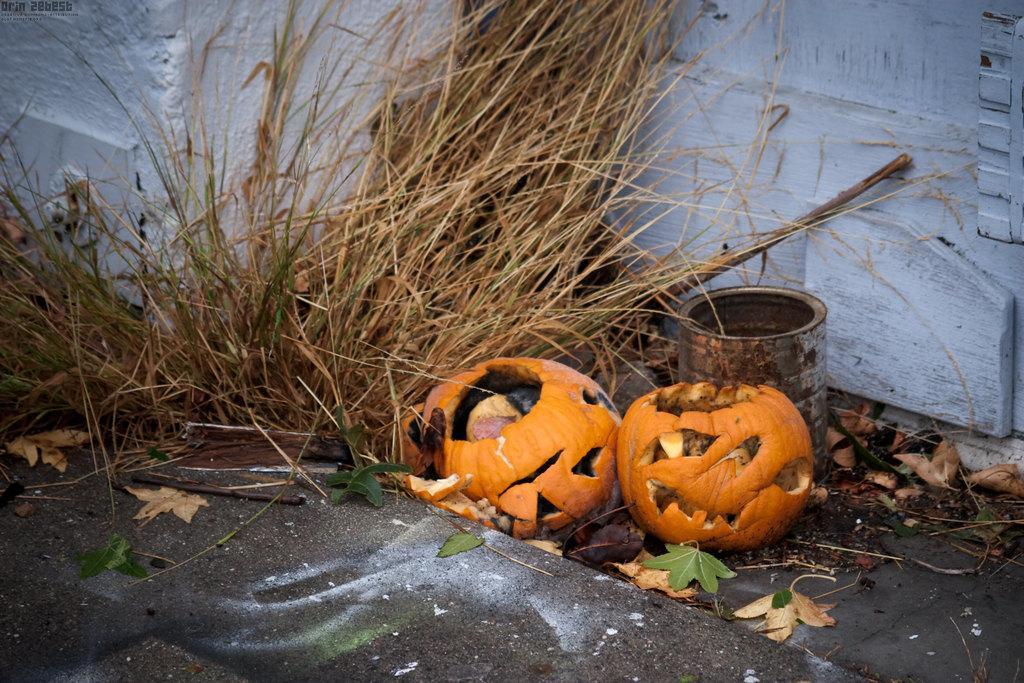How would you summarize this image in a sentence or two? In this picture we can see two pumpkins and a tin in the middle, at the bottom there are some leaves, in the background there is a wall and grass. 